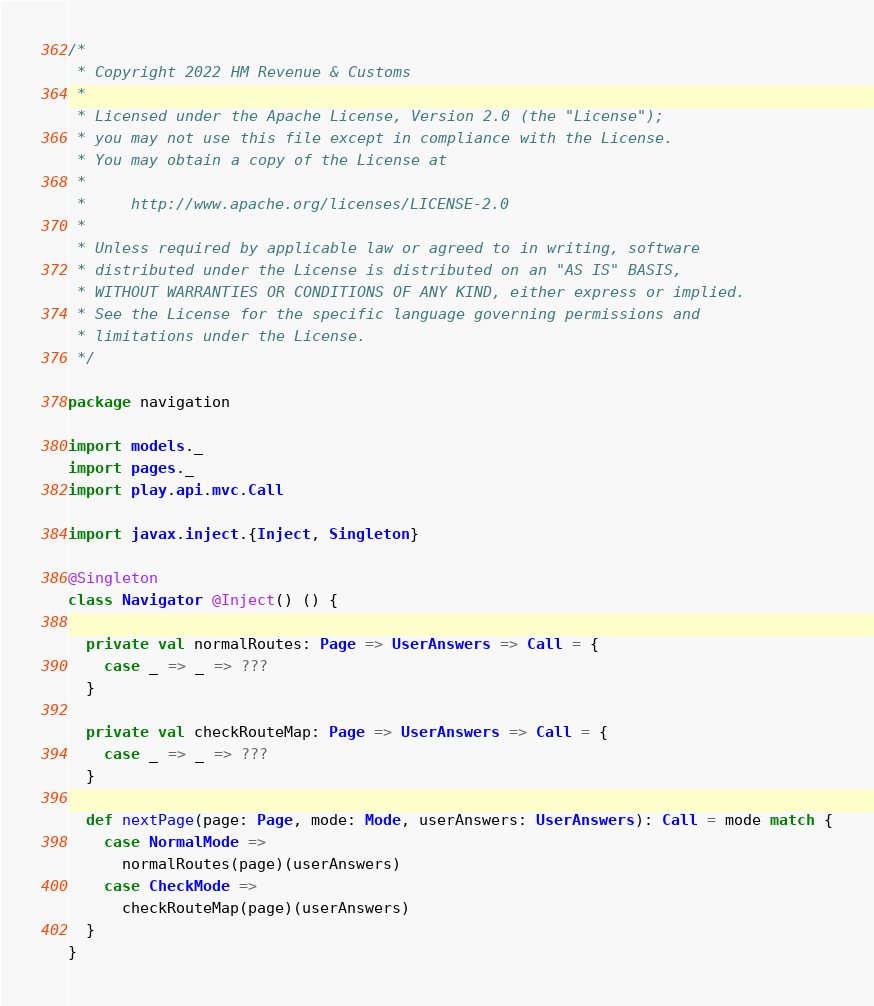<code> <loc_0><loc_0><loc_500><loc_500><_Scala_>/*
 * Copyright 2022 HM Revenue & Customs
 *
 * Licensed under the Apache License, Version 2.0 (the "License");
 * you may not use this file except in compliance with the License.
 * You may obtain a copy of the License at
 *
 *     http://www.apache.org/licenses/LICENSE-2.0
 *
 * Unless required by applicable law or agreed to in writing, software
 * distributed under the License is distributed on an "AS IS" BASIS,
 * WITHOUT WARRANTIES OR CONDITIONS OF ANY KIND, either express or implied.
 * See the License for the specific language governing permissions and
 * limitations under the License.
 */

package navigation

import models._
import pages._
import play.api.mvc.Call

import javax.inject.{Inject, Singleton}

@Singleton
class Navigator @Inject() () {

  private val normalRoutes: Page => UserAnswers => Call = {
    case _ => _ => ???
  }

  private val checkRouteMap: Page => UserAnswers => Call = {
    case _ => _ => ???
  }

  def nextPage(page: Page, mode: Mode, userAnswers: UserAnswers): Call = mode match {
    case NormalMode =>
      normalRoutes(page)(userAnswers)
    case CheckMode =>
      checkRouteMap(page)(userAnswers)
  }
}
</code> 